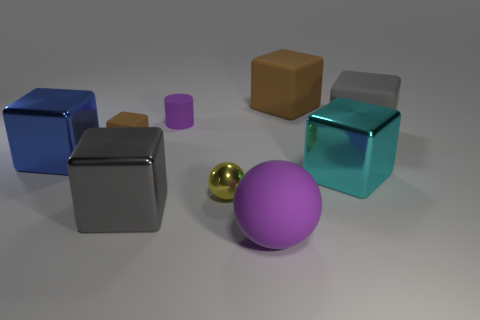Subtract all blue blocks. How many blocks are left? 5 Subtract all large gray metallic blocks. How many blocks are left? 5 Subtract 3 cubes. How many cubes are left? 3 Add 1 tiny brown metal blocks. How many objects exist? 10 Subtract all cyan blocks. Subtract all cyan balls. How many blocks are left? 5 Subtract all blocks. How many objects are left? 3 Subtract 0 purple cubes. How many objects are left? 9 Subtract all tiny cylinders. Subtract all purple cylinders. How many objects are left? 7 Add 3 small matte things. How many small matte things are left? 5 Add 4 small purple shiny objects. How many small purple shiny objects exist? 4 